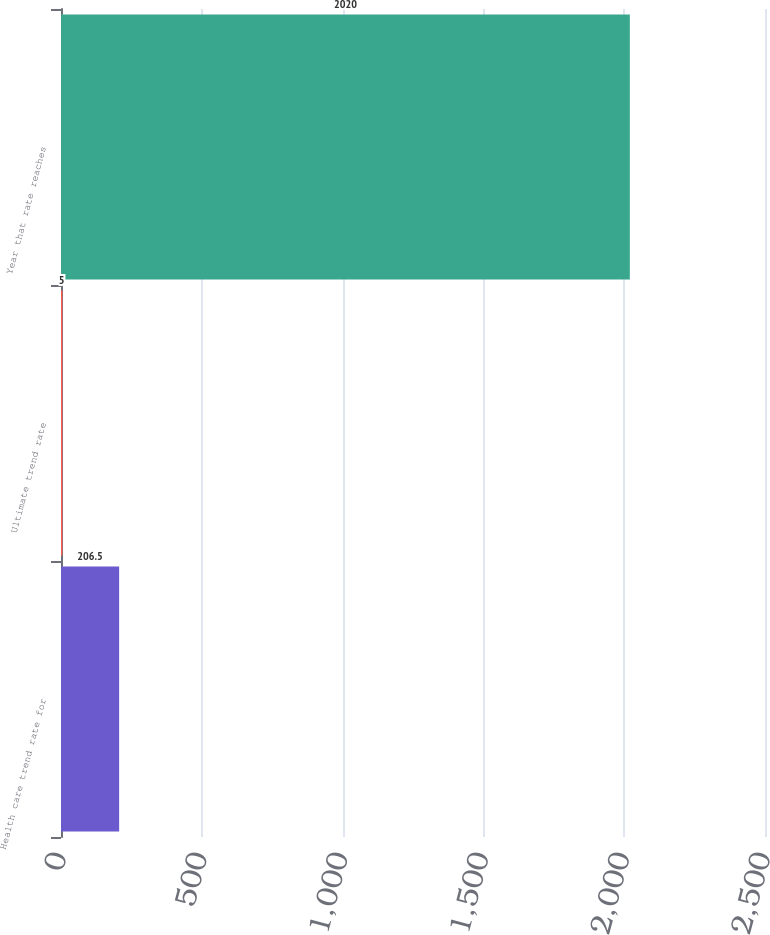<chart> <loc_0><loc_0><loc_500><loc_500><bar_chart><fcel>Health care trend rate for<fcel>Ultimate trend rate<fcel>Year that rate reaches<nl><fcel>206.5<fcel>5<fcel>2020<nl></chart> 